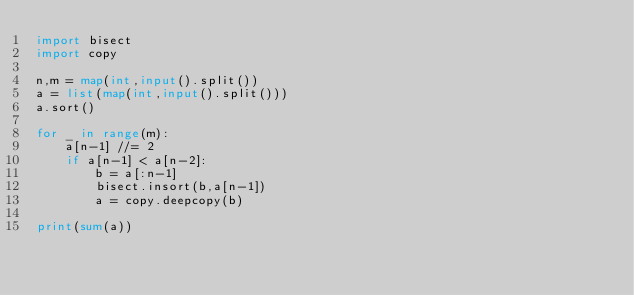<code> <loc_0><loc_0><loc_500><loc_500><_Python_>import bisect
import copy

n,m = map(int,input().split())
a = list(map(int,input().split()))
a.sort()

for _ in range(m):
    a[n-1] //= 2
    if a[n-1] < a[n-2]:
        b = a[:n-1]
        bisect.insort(b,a[n-1])
        a = copy.deepcopy(b)
    
print(sum(a))</code> 